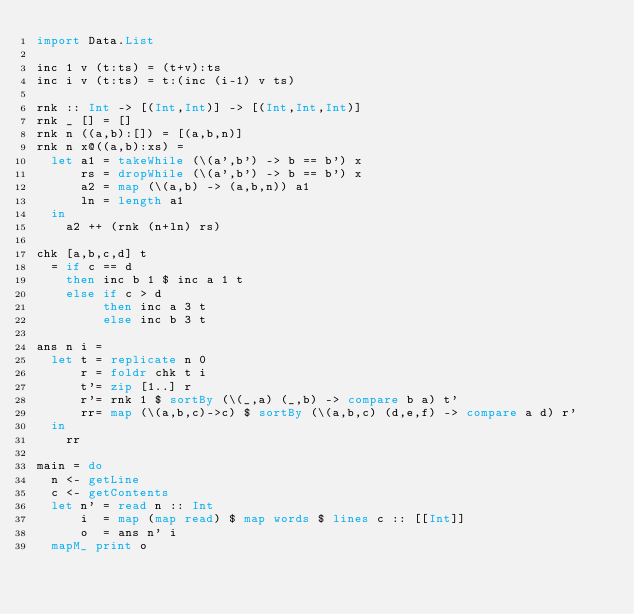<code> <loc_0><loc_0><loc_500><loc_500><_Haskell_>import Data.List

inc 1 v (t:ts) = (t+v):ts
inc i v (t:ts) = t:(inc (i-1) v ts)

rnk :: Int -> [(Int,Int)] -> [(Int,Int,Int)]
rnk _ [] = []
rnk n ((a,b):[]) = [(a,b,n)]
rnk n x@((a,b):xs) =
  let a1 = takeWhile (\(a',b') -> b == b') x
      rs = dropWhile (\(a',b') -> b == b') x
      a2 = map (\(a,b) -> (a,b,n)) a1
      ln = length a1
  in
    a2 ++ (rnk (n+ln) rs)

chk [a,b,c,d] t
  = if c == d
    then inc b 1 $ inc a 1 t
    else if c > d
         then inc a 3 t
         else inc b 3 t

ans n i =
  let t = replicate n 0
      r = foldr chk t i
      t'= zip [1..] r
      r'= rnk 1 $ sortBy (\(_,a) (_,b) -> compare b a) t'
      rr= map (\(a,b,c)->c) $ sortBy (\(a,b,c) (d,e,f) -> compare a d) r'
  in
    rr

main = do
  n <- getLine
  c <- getContents
  let n' = read n :: Int
      i  = map (map read) $ map words $ lines c :: [[Int]]
      o  = ans n' i
  mapM_ print o
  </code> 